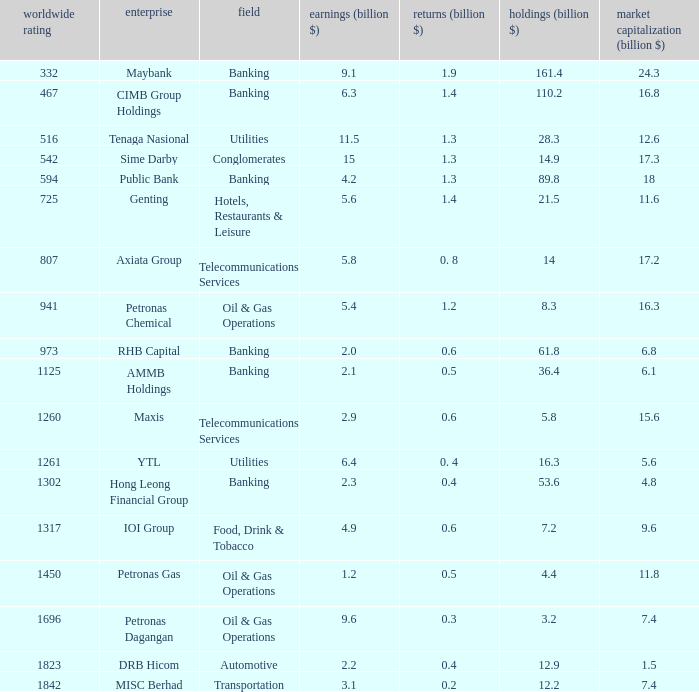Specify the international rank for market value 1 807.0. 